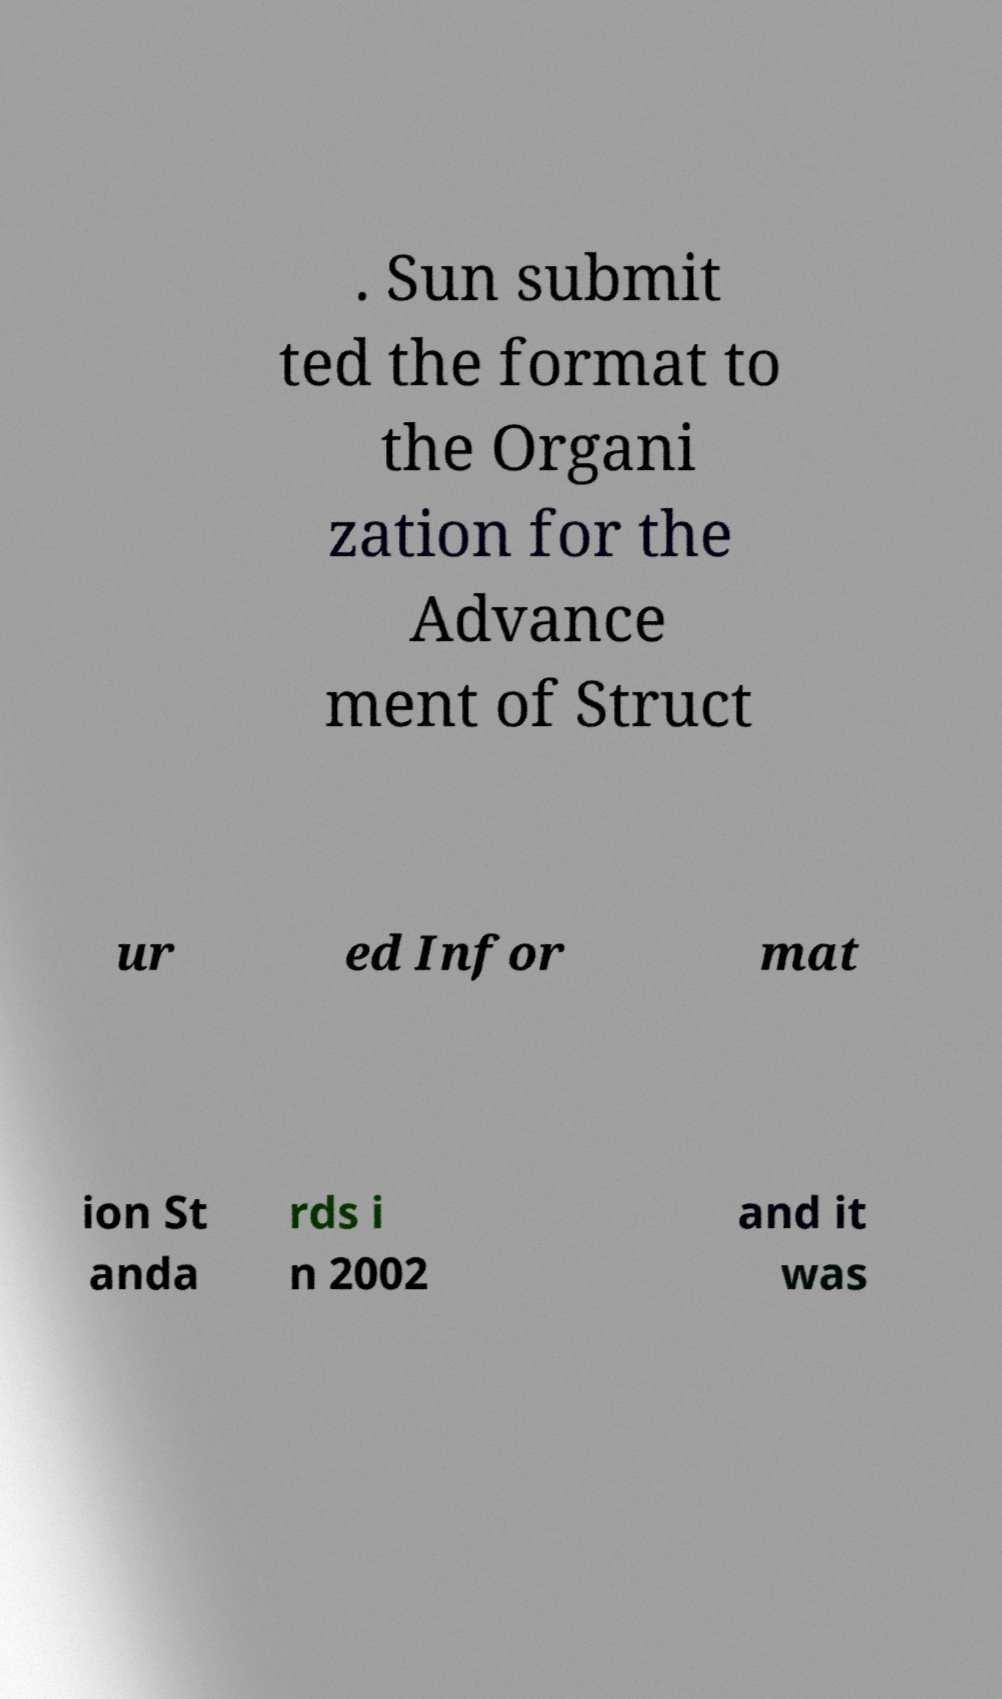There's text embedded in this image that I need extracted. Can you transcribe it verbatim? . Sun submit ted the format to the Organi zation for the Advance ment of Struct ur ed Infor mat ion St anda rds i n 2002 and it was 